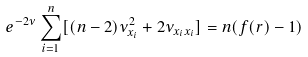<formula> <loc_0><loc_0><loc_500><loc_500>e ^ { - 2 \nu } \sum _ { i = 1 } ^ { n } [ { ( n - 2 ) \nu _ { x _ { i } } ^ { 2 } + 2 \nu _ { x _ { i } x _ { i } } } ] = n ( f ( r ) - 1 )</formula> 